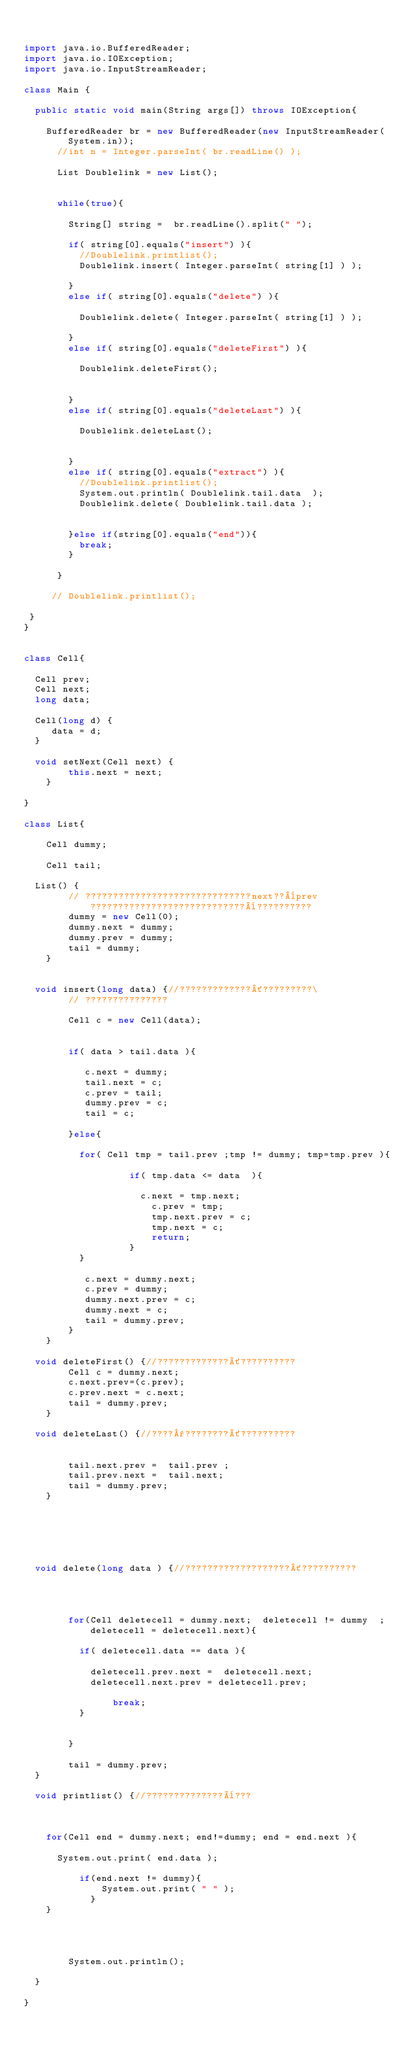Convert code to text. <code><loc_0><loc_0><loc_500><loc_500><_Java_>

import java.io.BufferedReader;
import java.io.IOException;
import java.io.InputStreamReader;

class Main {

  public static void main(String args[]) throws IOException{

	  BufferedReader br = new BufferedReader(new InputStreamReader(System.in));
      //int n = Integer.parseInt( br.readLine() );

      List Doublelink = new List();


      while(true){

    	  String[] string =  br.readLine().split(" ");

    	  if( string[0].equals("insert") ){
    		  //Doublelink.printlist();
    		  Doublelink.insert( Integer.parseInt( string[1] ) );

    	  }
    	  else if( string[0].equals("delete") ){

    		  Doublelink.delete( Integer.parseInt( string[1] ) );

    	  }
    	  else if( string[0].equals("deleteFirst") ){

    		  Doublelink.deleteFirst();


    	  }
    	  else if( string[0].equals("deleteLast") ){

    		  Doublelink.deleteLast();


    	  }
    	  else if( string[0].equals("extract") ){
    		  //Doublelink.printlist();
    		  System.out.println( Doublelink.tail.data  );
    		  Doublelink.delete( Doublelink.tail.data );


    	  }else if(string[0].equals("end")){
    		  break;
    	  }

      }

     // Doublelink.printlist();

 }
}


class Cell{

	Cell prev;
	Cell next;
	long data;

	Cell(long d) {
	   data = d;
	}

	void setNext(Cell next) {
        this.next = next;
    }

}

class List{

    Cell dummy;

    Cell tail;

	List() {
        // ??????????????????????????????next??¨prev????????????????????????????¨??????????
        dummy = new Cell(0);
        dummy.next = dummy;
        dummy.prev = dummy;
        tail = dummy;
    }


	void insert(long data) {//?????????????´?????????\
        // ???????????????

        Cell c = new Cell(data);


        if( data > tail.data ){

        	 c.next = dummy;
        	 tail.next = c;
        	 c.prev = tail;
        	 dummy.prev = c;
        	 tail = c;

        }else{

        	for( Cell tmp = tail.prev ;tmp != dummy; tmp=tmp.prev ){

                   if( tmp.data <= data  ){

                	   c.next = tmp.next;
                  	   c.prev = tmp;
                  	   tmp.next.prev = c;
                  	   tmp.next = c;
                  	   return;
                   }
        	}

           c.next = dummy.next;
           c.prev = dummy;
           dummy.next.prev = c;
           dummy.next = c;
           tail = dummy.prev;
        }
    }

	void deleteFirst() {//?????????????´??????????
        Cell c = dummy.next;
        c.next.prev=(c.prev);
        c.prev.next = c.next;
        tail = dummy.prev;
    }

	void deleteLast() {//????°????????´??????????


        tail.next.prev =  tail.prev ;
        tail.prev.next =  tail.next;
        tail = dummy.prev;
    }






	void delete(long data ) {//???????????????????´??????????




        for(Cell deletecell = dummy.next;  deletecell != dummy  ;  deletecell = deletecell.next){

        	if( deletecell.data == data ){

        		deletecell.prev.next =  deletecell.next;
        		deletecell.next.prev = deletecell.prev;

                break;
        	}


        }

        tail = dummy.prev;
	}

	void printlist() {//??????????????¨???



		for(Cell end = dummy.next; end!=dummy; end = end.next ){

			System.out.print( end.data );

        	if(end.next != dummy){
            	System.out.print( " " );
            }
		}




        System.out.println();

	}

}</code> 